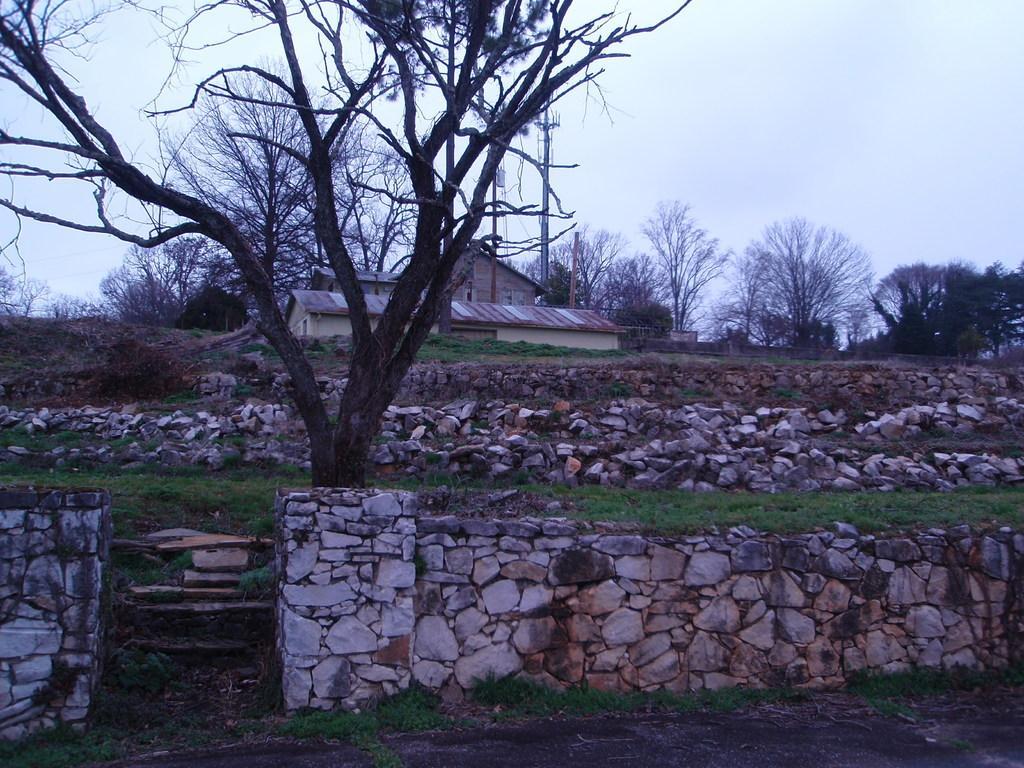Could you give a brief overview of what you see in this image? In this image, we can see some trees and rock walls. There are shelter houses and poles in the middle of the image. At the top of the image, we can see the sky. 